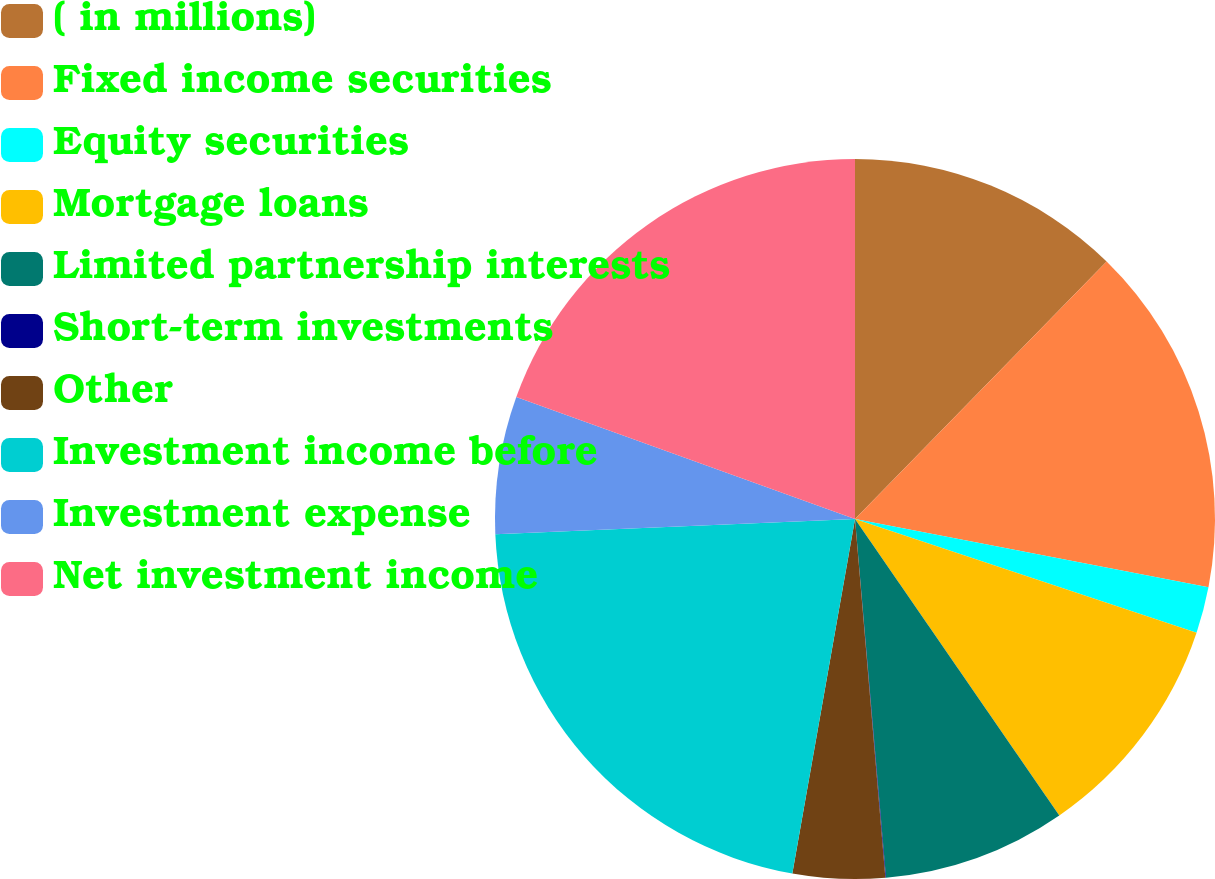<chart> <loc_0><loc_0><loc_500><loc_500><pie_chart><fcel>( in millions)<fcel>Fixed income securities<fcel>Equity securities<fcel>Mortgage loans<fcel>Limited partnership interests<fcel>Short-term investments<fcel>Other<fcel>Investment income before<fcel>Investment expense<fcel>Net investment income<nl><fcel>12.32%<fcel>15.72%<fcel>2.08%<fcel>10.28%<fcel>8.23%<fcel>0.03%<fcel>4.13%<fcel>21.54%<fcel>6.18%<fcel>19.5%<nl></chart> 